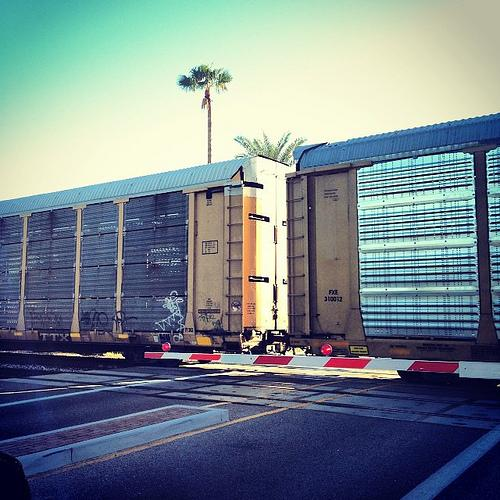Write a sentence describing the atmosphere of the image. A bustling street scene unfolds as a yellow train with graffiti passes through an intersection guarded by a red and white railroad railing. Narrate the scene in the image using a descriptive sentence. The yellow train cars pass over the train tracks on the road as the red and white railroad railing protects the intersection. Describe the primary focus of the image emphasizing the color elements. A yellow train with black graffiti crosses a street alongside a red and white railroad railing and a green palm tree. Summarize the main elements in the picture with an emphasis on the background. A train crosses a street, with train tracks, a brick and cement median, and tall palm trees as noteworthy background elements. Compose a brief overview of the image content. This image showcases a train crossing a road with a red and white caution arm, train tracks, graffiti, and a tall palm tree behind. Express the main action happening in the image in a concise manner. A train with graffiti travels through an intersection with a large palm tree behind it. Give a brief explanation of the main subject in the image and its surroundings. A train with graffiti makes its way through a busy street intersection, accompanied by a red and white railroad railing, and a tall palm tree in the background. List the most prominent features of this picture. Yellow train cars, red and white crossing bar, train tracks, tall palm tree, graffiti, and red lights. Provide a short description of the image focusing on the infrastructure in the scene. A train travels through an urban intersection, complete with train tracks, a brick and cement median, and a tall palm tree enhancing the cityscape. Write a short statement about the primary focus of the image. A train crossing a street with a red and white caution arm and tall palm trees in the background. 